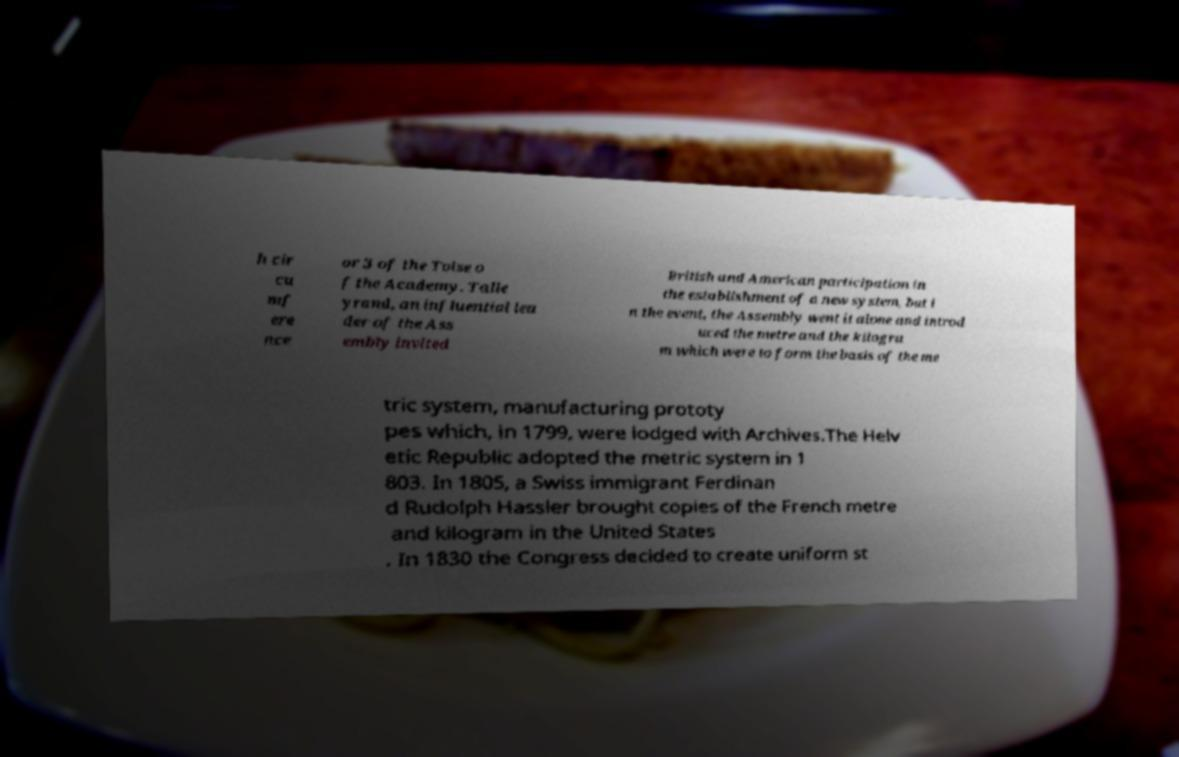I need the written content from this picture converted into text. Can you do that? h cir cu mf ere nce or 3 of the Toise o f the Academy. Talle yrand, an influential lea der of the Ass embly invited British and American participation in the establishment of a new system, but i n the event, the Assembly went it alone and introd uced the metre and the kilogra m which were to form the basis of the me tric system, manufacturing prototy pes which, in 1799, were lodged with Archives.The Helv etic Republic adopted the metric system in 1 803. In 1805, a Swiss immigrant Ferdinan d Rudolph Hassler brought copies of the French metre and kilogram in the United States . In 1830 the Congress decided to create uniform st 